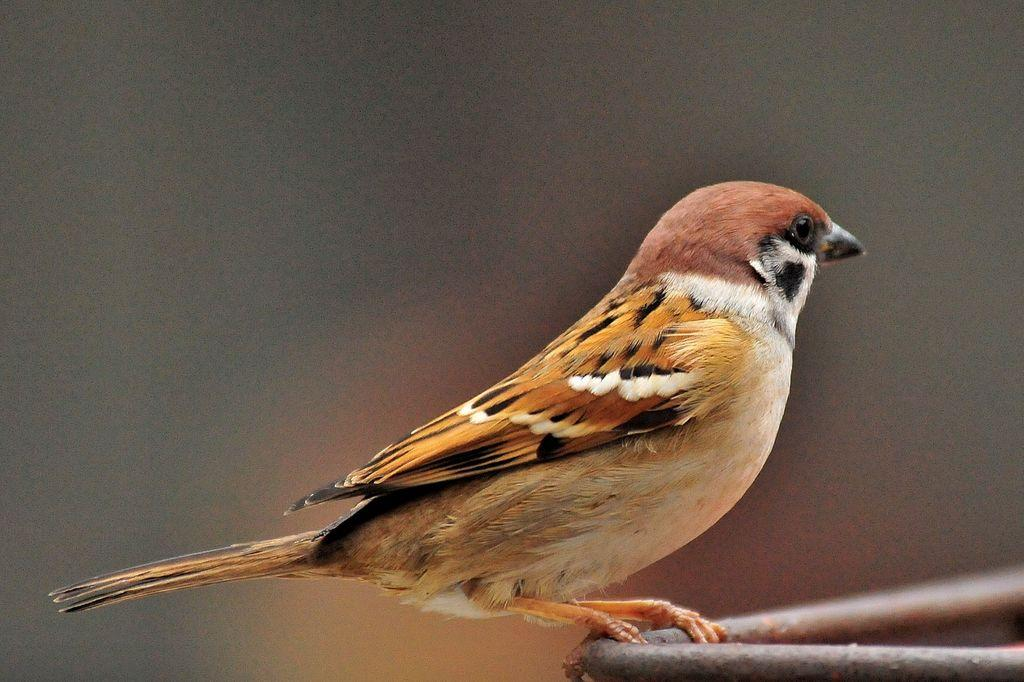What is the main subject of the picture? The main subject of the picture is a bird. Where is the bird located in the image? The bird is standing on an iron rod. What does the bird say to its owner in the image? There is no indication in the image that the bird has an owner or can speak, so it cannot be determined from the picture. 